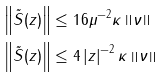<formula> <loc_0><loc_0><loc_500><loc_500>\left \| \tilde { S } ( z ) \right \| & \leq 1 6 \mu ^ { - 2 } \kappa \left \| \nu \right \| \\ \left \| \tilde { S } ( z ) \right \| & \leq 4 \left | z \right | ^ { - 2 } \kappa \left \| \nu \right \|</formula> 